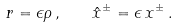Convert formula to latex. <formula><loc_0><loc_0><loc_500><loc_500>r = \epsilon \rho \, , \quad \hat { x } ^ { \pm } = \epsilon \, x ^ { \pm } \, .</formula> 